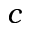Convert formula to latex. <formula><loc_0><loc_0><loc_500><loc_500>c</formula> 